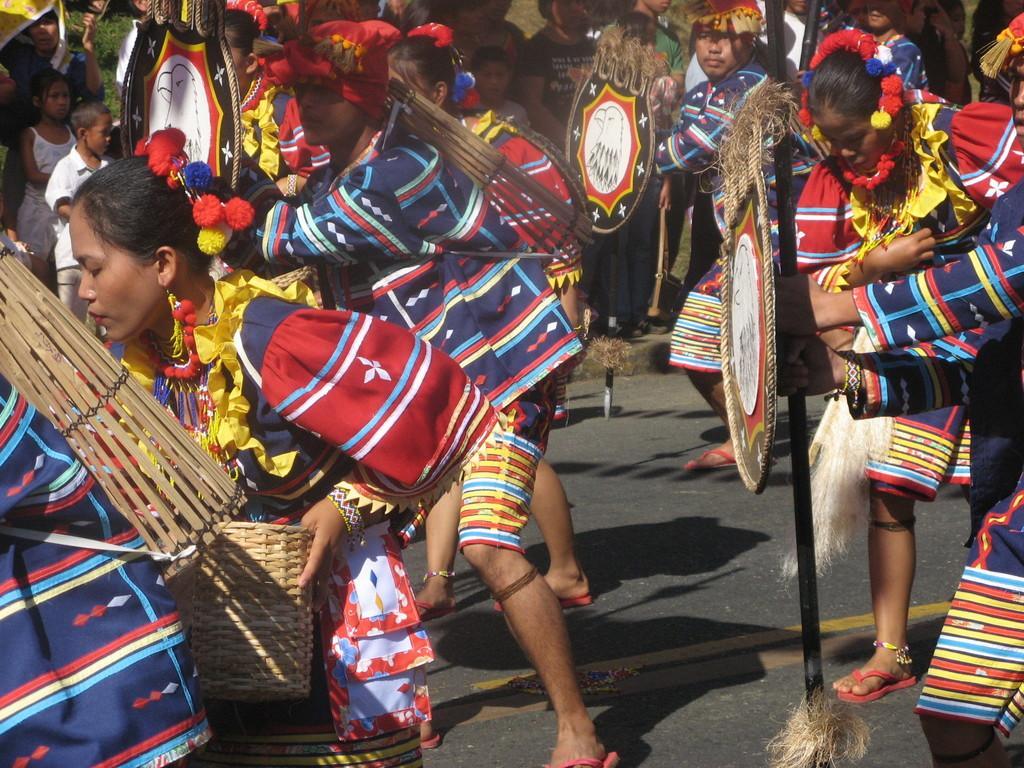Please provide a concise description of this image. In this picture we can see a few people holding some objects in there hands and these people seems like dancing on road. In this image we can also see in the background, some people are standing. 